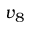<formula> <loc_0><loc_0><loc_500><loc_500>v _ { 8 }</formula> 